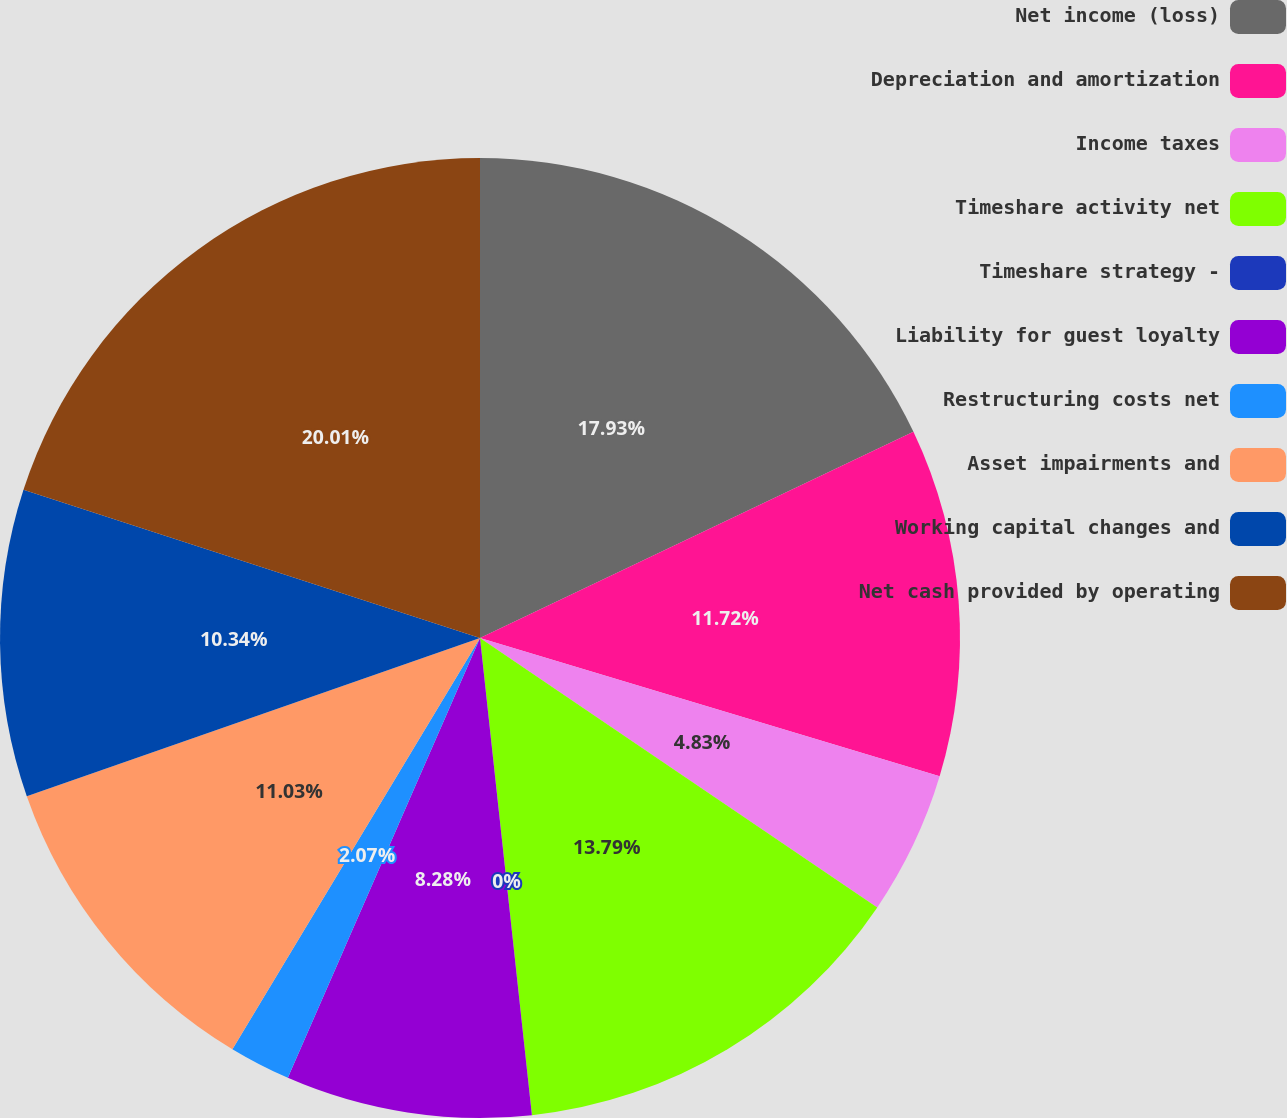<chart> <loc_0><loc_0><loc_500><loc_500><pie_chart><fcel>Net income (loss)<fcel>Depreciation and amortization<fcel>Income taxes<fcel>Timeshare activity net<fcel>Timeshare strategy -<fcel>Liability for guest loyalty<fcel>Restructuring costs net<fcel>Asset impairments and<fcel>Working capital changes and<fcel>Net cash provided by operating<nl><fcel>17.93%<fcel>11.72%<fcel>4.83%<fcel>13.79%<fcel>0.0%<fcel>8.28%<fcel>2.07%<fcel>11.03%<fcel>10.34%<fcel>20.0%<nl></chart> 